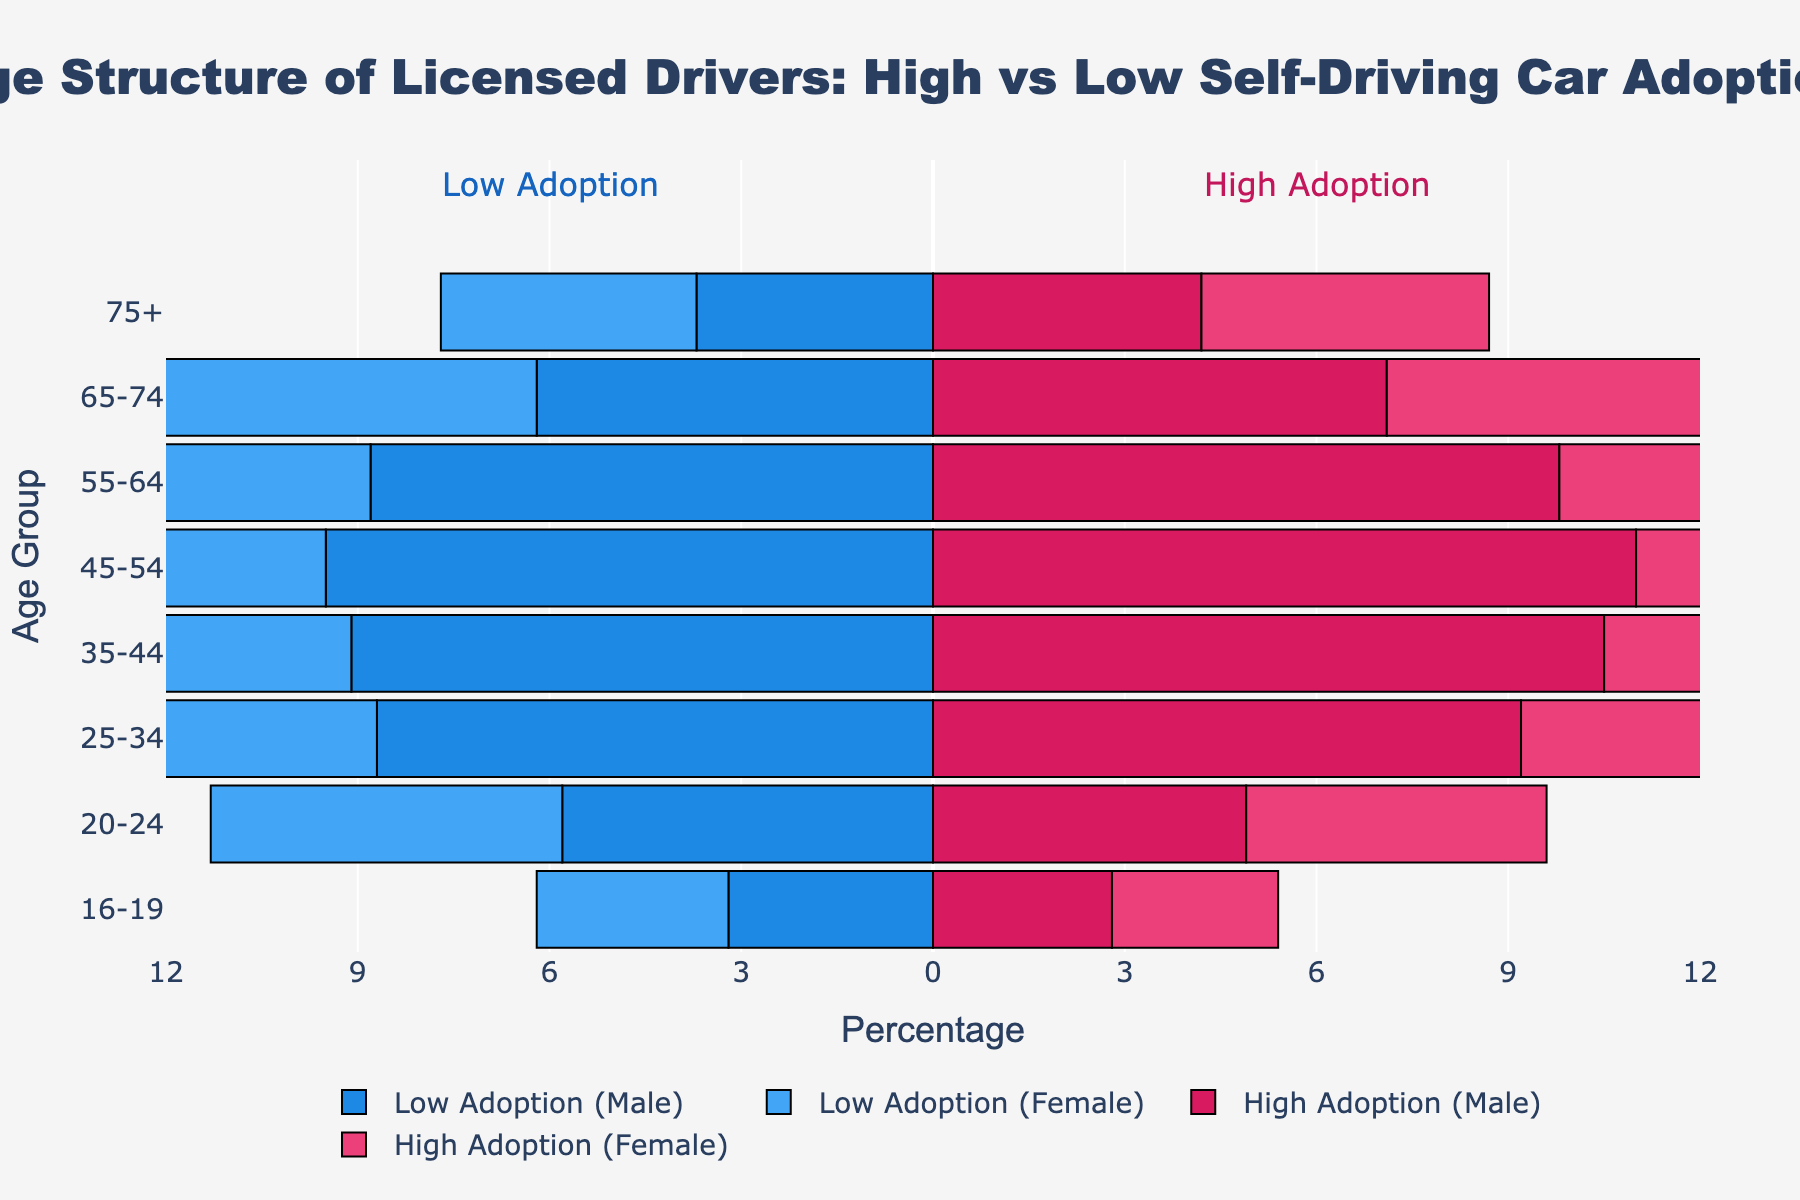What age group has the highest percentage of licensed male drivers in high adoption regions? By looking at the height of the bars for male drivers in high self-driving car adoption regions, the '35-44' age group has the highest value of 10.5%.
Answer: 35-44 What is the difference in the percentage of licensed female drivers aged 65-74 between high adoption and low adoption regions? For the '65-74' age group, the percentage for females in high adoption regions is 7.3%, and in low adoption regions, it is 6.4%. The difference is 7.3% - 6.4% = 0.9%.
Answer: 0.9% Which gender has a higher percentage of licensed drivers in the '20-24' age group for low adoption regions? Comparing the '20-24' age group in low adoption regions, males are at 5.8% and females are at 5.5%. Therefore, males have a higher percentage.
Answer: Males What is the total percentage of licensed female drivers in the '55-64' age group across both regions? Adding the '55-64' age group female percentages from both regions: 8.7% (low adoption) + 9.6% (high adoption) = 18.3%.
Answer: 18.3% How does the percentage of licensed male drivers aged 45-54 compare between high and low adoption regions? The percentage for males aged 45-54 is 11.0% in high adoption regions and 9.5% in low adoption regions. The high adoption regions have a higher percentage by 11.0% - 9.5% = 1.5%.
Answer: Higher by 1.5% What is the overall trend observed in the age group '16-19' comparing low and high adoption regions? In the '16-19' age group, both males (3.2% to 2.8%) and females (3.0% to 2.6%) have lower percentages in high adoption regions than in low adoption regions, indicating a general trend of fewer young drivers in high adoption regions.
Answer: Fewer young drivers in high adoption regions Which age group exhibits the largest gender disparity in low adoption regions? Gender disparity can be calculated by the absolute difference between male and female percentages in each age group. The '20-24' age group shows the largest disparity:
Answer: 0.3% In high adoption regions, which age group has the smallest combined percentage of male and female drivers? Adding both male and female percentages for each age group in high adoption regions, the '16-19' age group has the smallest combined percentage: 2.8% + 2.6% = 5.4%.
Answer: 16-19 